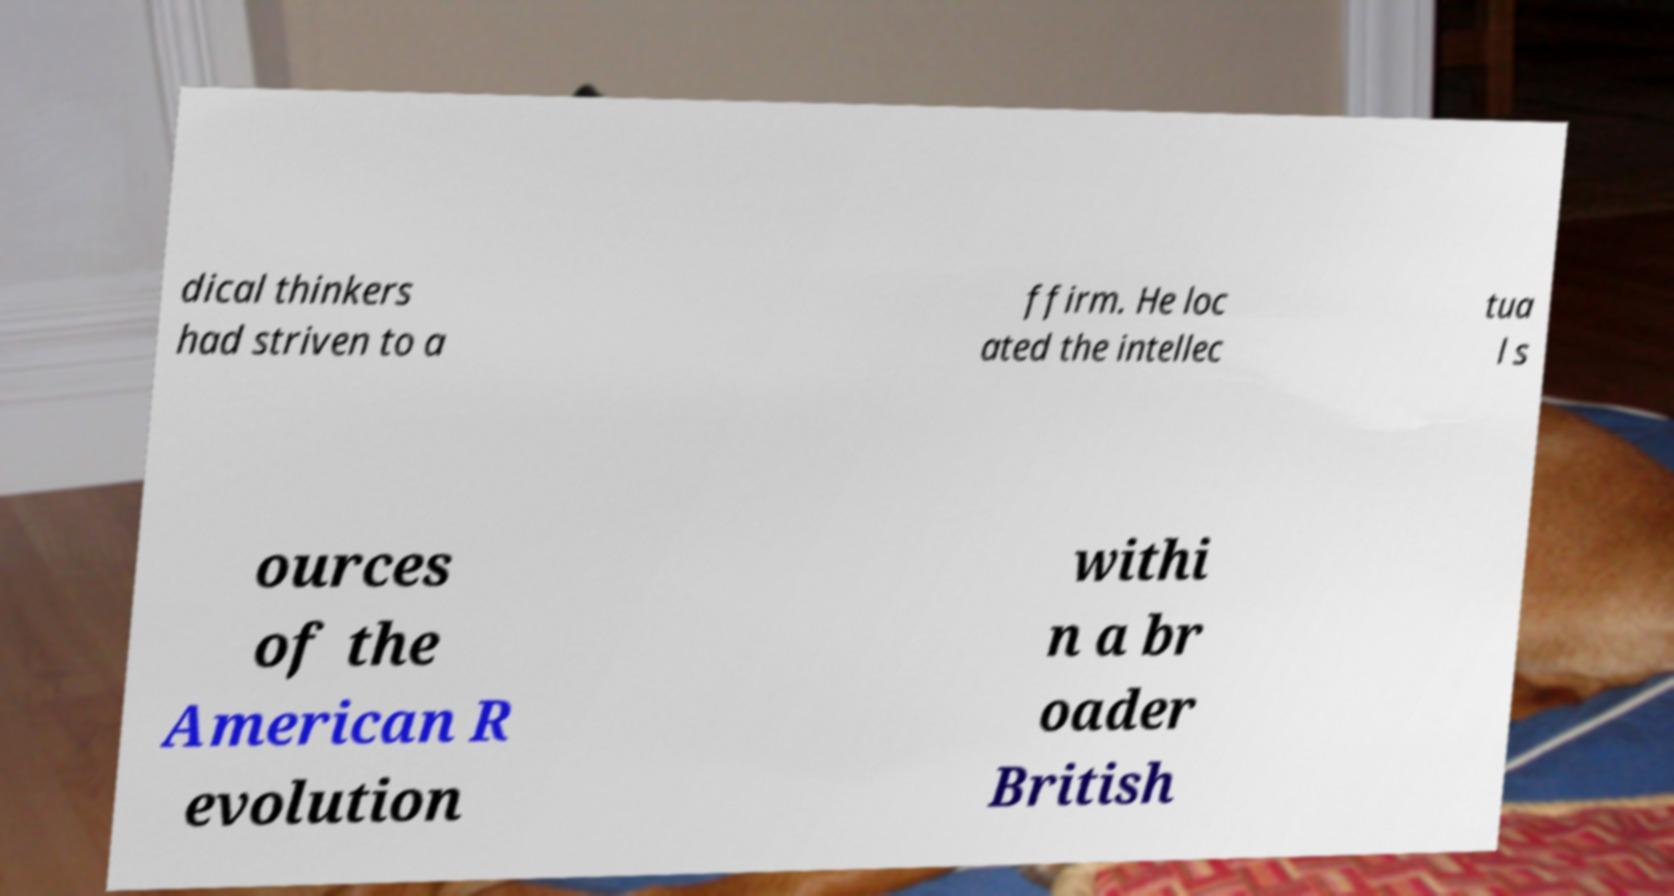Can you accurately transcribe the text from the provided image for me? dical thinkers had striven to a ffirm. He loc ated the intellec tua l s ources of the American R evolution withi n a br oader British 